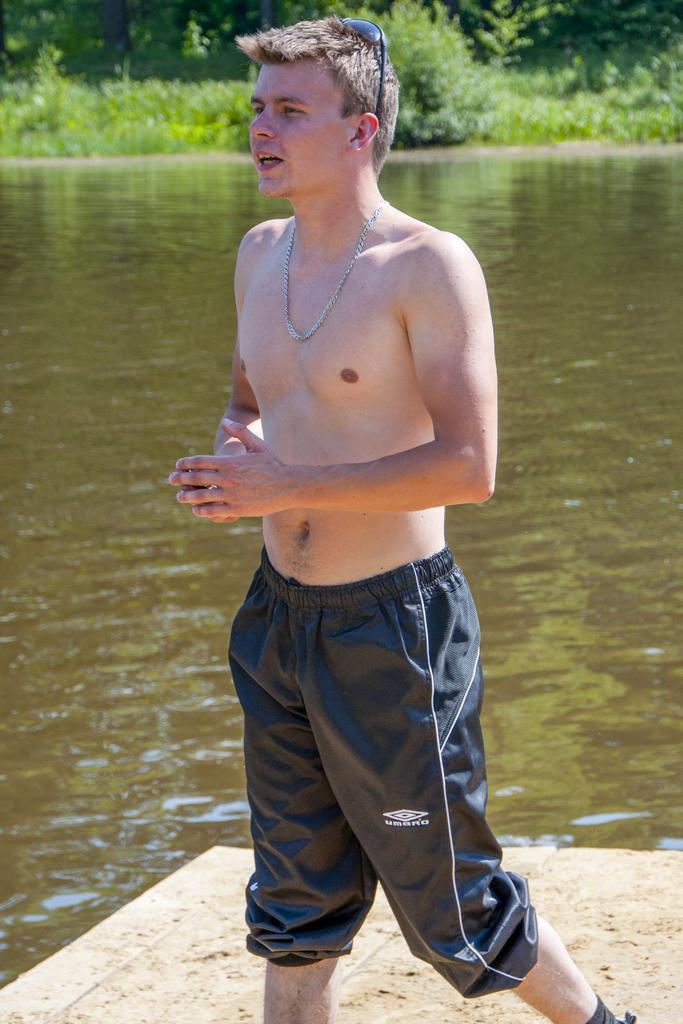In one or two sentences, can you explain what this image depicts? In this image there is a man standing on the floor without the shirt. In the background there is water. Beside the water there are small plants. 